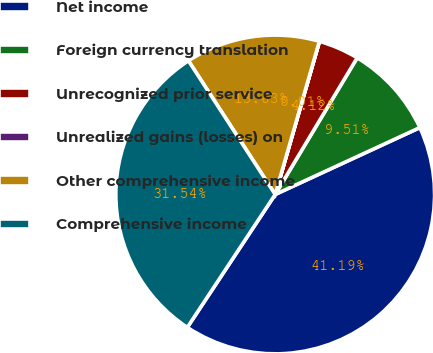Convert chart to OTSL. <chart><loc_0><loc_0><loc_500><loc_500><pie_chart><fcel>Net income<fcel>Foreign currency translation<fcel>Unrecognized prior service<fcel>Unrealized gains (losses) on<fcel>Other comprehensive income<fcel>Comprehensive income<nl><fcel>41.19%<fcel>9.51%<fcel>4.12%<fcel>0.01%<fcel>13.63%<fcel>31.54%<nl></chart> 